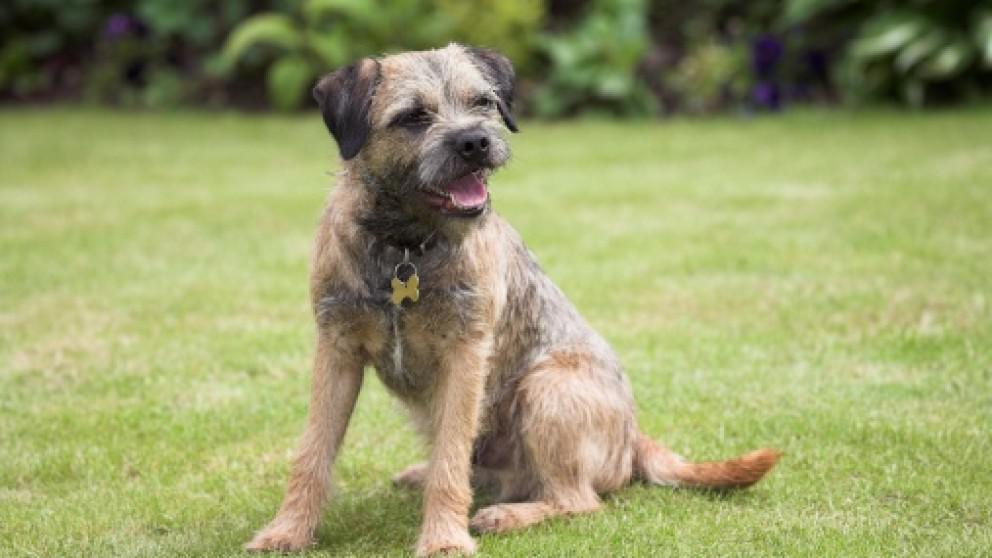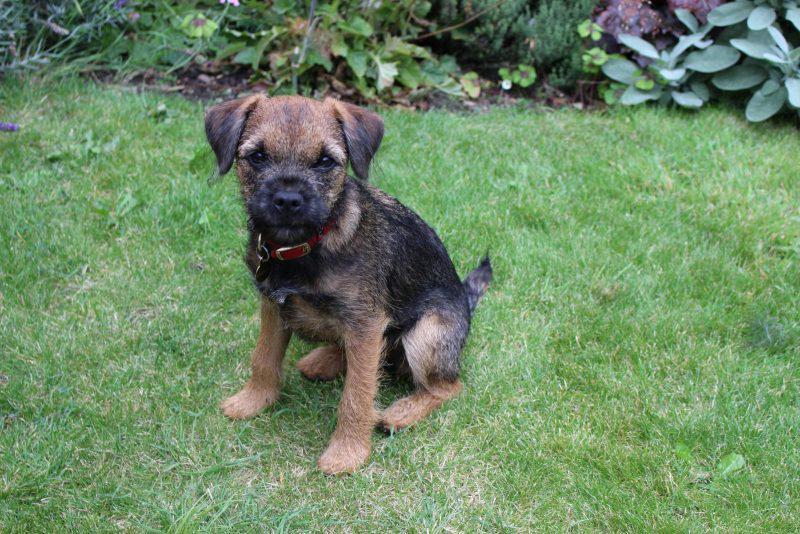The first image is the image on the left, the second image is the image on the right. Given the left and right images, does the statement "In both images, there's a border terrier sitting down." hold true? Answer yes or no. Yes. The first image is the image on the left, the second image is the image on the right. Considering the images on both sides, is "There is a dog outside in the grass in the center of both of the images." valid? Answer yes or no. Yes. 